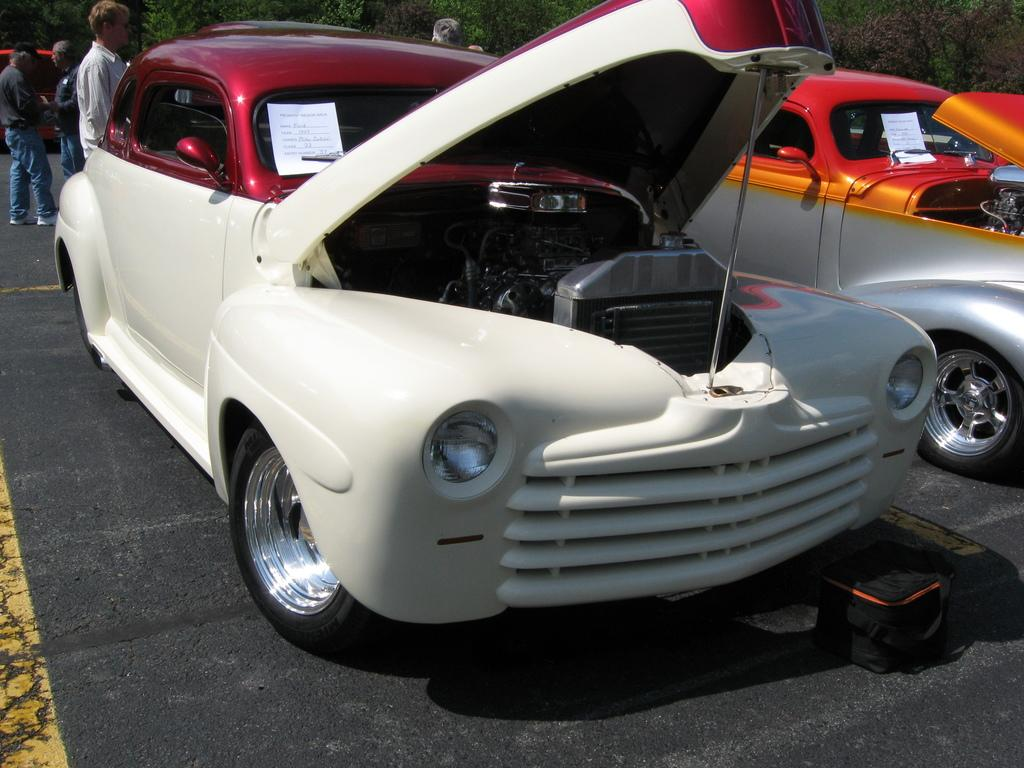What is present in the image? There are vehicles in the image. Can you describe one of the vehicles? One of the vehicles is red and white. What can be seen in the background of the image? There are people standing and trees with green color in the background of the image. What type of flesh can be seen on the vehicles in the image? There is no flesh present on the vehicles in the image; they are inanimate objects. 